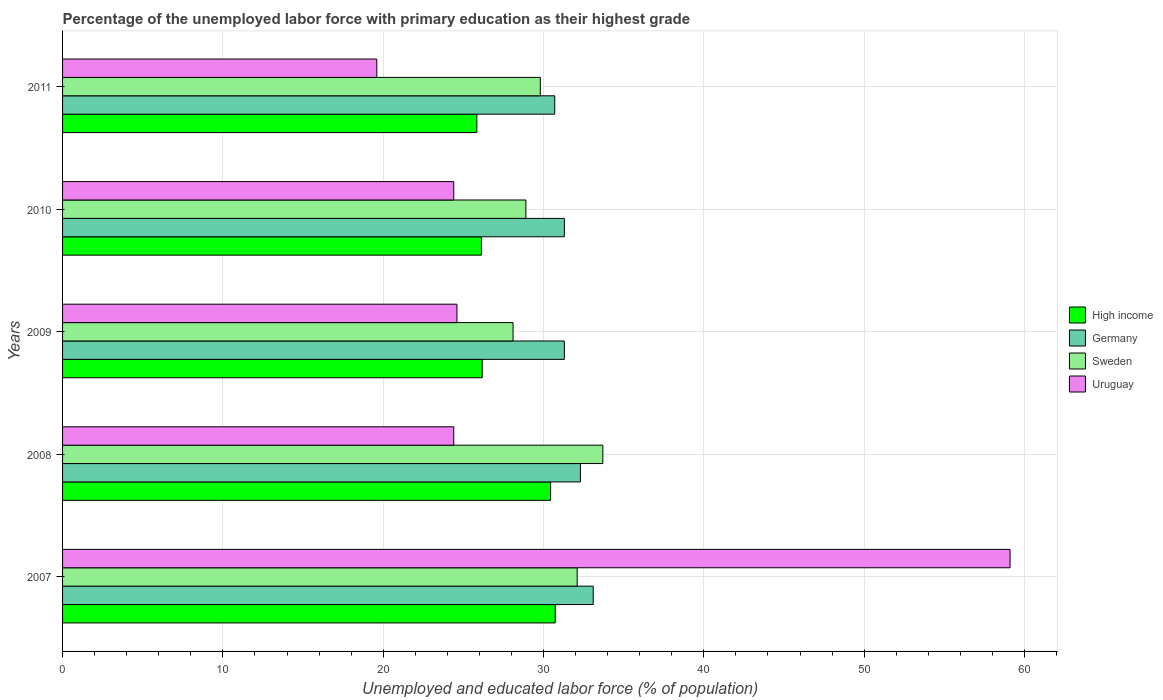Are the number of bars on each tick of the Y-axis equal?
Give a very brief answer. Yes. How many bars are there on the 3rd tick from the top?
Give a very brief answer. 4. How many bars are there on the 4th tick from the bottom?
Offer a very short reply. 4. What is the label of the 5th group of bars from the top?
Ensure brevity in your answer.  2007. What is the percentage of the unemployed labor force with primary education in Germany in 2011?
Provide a succinct answer. 30.7. Across all years, what is the maximum percentage of the unemployed labor force with primary education in Sweden?
Offer a very short reply. 33.7. Across all years, what is the minimum percentage of the unemployed labor force with primary education in High income?
Offer a terse response. 25.84. What is the total percentage of the unemployed labor force with primary education in Germany in the graph?
Give a very brief answer. 158.7. What is the difference between the percentage of the unemployed labor force with primary education in High income in 2008 and that in 2010?
Give a very brief answer. 4.32. What is the difference between the percentage of the unemployed labor force with primary education in Uruguay in 2011 and the percentage of the unemployed labor force with primary education in Germany in 2008?
Make the answer very short. -12.7. What is the average percentage of the unemployed labor force with primary education in Sweden per year?
Offer a terse response. 30.52. In the year 2011, what is the difference between the percentage of the unemployed labor force with primary education in Uruguay and percentage of the unemployed labor force with primary education in Germany?
Ensure brevity in your answer.  -11.1. What is the ratio of the percentage of the unemployed labor force with primary education in Sweden in 2008 to that in 2009?
Your response must be concise. 1.2. What is the difference between the highest and the second highest percentage of the unemployed labor force with primary education in Sweden?
Provide a succinct answer. 1.6. What is the difference between the highest and the lowest percentage of the unemployed labor force with primary education in Sweden?
Provide a succinct answer. 5.6. In how many years, is the percentage of the unemployed labor force with primary education in Sweden greater than the average percentage of the unemployed labor force with primary education in Sweden taken over all years?
Ensure brevity in your answer.  2. Is the sum of the percentage of the unemployed labor force with primary education in Sweden in 2008 and 2011 greater than the maximum percentage of the unemployed labor force with primary education in High income across all years?
Offer a very short reply. Yes. What does the 1st bar from the top in 2010 represents?
Your response must be concise. Uruguay. What does the 4th bar from the bottom in 2007 represents?
Provide a succinct answer. Uruguay. How many bars are there?
Offer a terse response. 20. Are all the bars in the graph horizontal?
Make the answer very short. Yes. Does the graph contain any zero values?
Give a very brief answer. No. Where does the legend appear in the graph?
Provide a short and direct response. Center right. How are the legend labels stacked?
Provide a short and direct response. Vertical. What is the title of the graph?
Give a very brief answer. Percentage of the unemployed labor force with primary education as their highest grade. Does "United Arab Emirates" appear as one of the legend labels in the graph?
Your answer should be very brief. No. What is the label or title of the X-axis?
Provide a succinct answer. Unemployed and educated labor force (% of population). What is the label or title of the Y-axis?
Give a very brief answer. Years. What is the Unemployed and educated labor force (% of population) in High income in 2007?
Keep it short and to the point. 30.73. What is the Unemployed and educated labor force (% of population) in Germany in 2007?
Your answer should be very brief. 33.1. What is the Unemployed and educated labor force (% of population) of Sweden in 2007?
Provide a short and direct response. 32.1. What is the Unemployed and educated labor force (% of population) in Uruguay in 2007?
Offer a terse response. 59.1. What is the Unemployed and educated labor force (% of population) of High income in 2008?
Provide a short and direct response. 30.44. What is the Unemployed and educated labor force (% of population) in Germany in 2008?
Keep it short and to the point. 32.3. What is the Unemployed and educated labor force (% of population) of Sweden in 2008?
Ensure brevity in your answer.  33.7. What is the Unemployed and educated labor force (% of population) in Uruguay in 2008?
Give a very brief answer. 24.4. What is the Unemployed and educated labor force (% of population) in High income in 2009?
Keep it short and to the point. 26.18. What is the Unemployed and educated labor force (% of population) in Germany in 2009?
Your answer should be very brief. 31.3. What is the Unemployed and educated labor force (% of population) in Sweden in 2009?
Your answer should be very brief. 28.1. What is the Unemployed and educated labor force (% of population) of Uruguay in 2009?
Your answer should be compact. 24.6. What is the Unemployed and educated labor force (% of population) in High income in 2010?
Provide a short and direct response. 26.13. What is the Unemployed and educated labor force (% of population) of Germany in 2010?
Your answer should be very brief. 31.3. What is the Unemployed and educated labor force (% of population) of Sweden in 2010?
Provide a succinct answer. 28.9. What is the Unemployed and educated labor force (% of population) of Uruguay in 2010?
Your answer should be compact. 24.4. What is the Unemployed and educated labor force (% of population) of High income in 2011?
Your answer should be compact. 25.84. What is the Unemployed and educated labor force (% of population) in Germany in 2011?
Your answer should be very brief. 30.7. What is the Unemployed and educated labor force (% of population) in Sweden in 2011?
Your answer should be compact. 29.8. What is the Unemployed and educated labor force (% of population) in Uruguay in 2011?
Make the answer very short. 19.6. Across all years, what is the maximum Unemployed and educated labor force (% of population) in High income?
Keep it short and to the point. 30.73. Across all years, what is the maximum Unemployed and educated labor force (% of population) in Germany?
Keep it short and to the point. 33.1. Across all years, what is the maximum Unemployed and educated labor force (% of population) of Sweden?
Keep it short and to the point. 33.7. Across all years, what is the maximum Unemployed and educated labor force (% of population) in Uruguay?
Offer a terse response. 59.1. Across all years, what is the minimum Unemployed and educated labor force (% of population) of High income?
Your answer should be very brief. 25.84. Across all years, what is the minimum Unemployed and educated labor force (% of population) of Germany?
Give a very brief answer. 30.7. Across all years, what is the minimum Unemployed and educated labor force (% of population) in Sweden?
Offer a terse response. 28.1. Across all years, what is the minimum Unemployed and educated labor force (% of population) of Uruguay?
Make the answer very short. 19.6. What is the total Unemployed and educated labor force (% of population) in High income in the graph?
Your answer should be very brief. 139.32. What is the total Unemployed and educated labor force (% of population) of Germany in the graph?
Offer a terse response. 158.7. What is the total Unemployed and educated labor force (% of population) in Sweden in the graph?
Make the answer very short. 152.6. What is the total Unemployed and educated labor force (% of population) of Uruguay in the graph?
Your answer should be compact. 152.1. What is the difference between the Unemployed and educated labor force (% of population) of High income in 2007 and that in 2008?
Your response must be concise. 0.29. What is the difference between the Unemployed and educated labor force (% of population) of Germany in 2007 and that in 2008?
Offer a terse response. 0.8. What is the difference between the Unemployed and educated labor force (% of population) in Uruguay in 2007 and that in 2008?
Offer a terse response. 34.7. What is the difference between the Unemployed and educated labor force (% of population) of High income in 2007 and that in 2009?
Make the answer very short. 4.55. What is the difference between the Unemployed and educated labor force (% of population) of Germany in 2007 and that in 2009?
Your answer should be very brief. 1.8. What is the difference between the Unemployed and educated labor force (% of population) of Uruguay in 2007 and that in 2009?
Make the answer very short. 34.5. What is the difference between the Unemployed and educated labor force (% of population) in High income in 2007 and that in 2010?
Provide a short and direct response. 4.61. What is the difference between the Unemployed and educated labor force (% of population) in Sweden in 2007 and that in 2010?
Offer a terse response. 3.2. What is the difference between the Unemployed and educated labor force (% of population) in Uruguay in 2007 and that in 2010?
Make the answer very short. 34.7. What is the difference between the Unemployed and educated labor force (% of population) of High income in 2007 and that in 2011?
Offer a very short reply. 4.89. What is the difference between the Unemployed and educated labor force (% of population) of Germany in 2007 and that in 2011?
Offer a very short reply. 2.4. What is the difference between the Unemployed and educated labor force (% of population) in Uruguay in 2007 and that in 2011?
Offer a very short reply. 39.5. What is the difference between the Unemployed and educated labor force (% of population) in High income in 2008 and that in 2009?
Make the answer very short. 4.26. What is the difference between the Unemployed and educated labor force (% of population) of Uruguay in 2008 and that in 2009?
Your response must be concise. -0.2. What is the difference between the Unemployed and educated labor force (% of population) in High income in 2008 and that in 2010?
Provide a short and direct response. 4.32. What is the difference between the Unemployed and educated labor force (% of population) of Sweden in 2008 and that in 2010?
Offer a very short reply. 4.8. What is the difference between the Unemployed and educated labor force (% of population) in High income in 2008 and that in 2011?
Provide a succinct answer. 4.6. What is the difference between the Unemployed and educated labor force (% of population) of Germany in 2008 and that in 2011?
Ensure brevity in your answer.  1.6. What is the difference between the Unemployed and educated labor force (% of population) of Sweden in 2008 and that in 2011?
Ensure brevity in your answer.  3.9. What is the difference between the Unemployed and educated labor force (% of population) in Uruguay in 2008 and that in 2011?
Provide a short and direct response. 4.8. What is the difference between the Unemployed and educated labor force (% of population) of High income in 2009 and that in 2010?
Ensure brevity in your answer.  0.05. What is the difference between the Unemployed and educated labor force (% of population) of Uruguay in 2009 and that in 2010?
Offer a very short reply. 0.2. What is the difference between the Unemployed and educated labor force (% of population) in High income in 2009 and that in 2011?
Provide a succinct answer. 0.33. What is the difference between the Unemployed and educated labor force (% of population) in Uruguay in 2009 and that in 2011?
Your answer should be very brief. 5. What is the difference between the Unemployed and educated labor force (% of population) of High income in 2010 and that in 2011?
Offer a terse response. 0.28. What is the difference between the Unemployed and educated labor force (% of population) of Uruguay in 2010 and that in 2011?
Make the answer very short. 4.8. What is the difference between the Unemployed and educated labor force (% of population) in High income in 2007 and the Unemployed and educated labor force (% of population) in Germany in 2008?
Your answer should be very brief. -1.57. What is the difference between the Unemployed and educated labor force (% of population) in High income in 2007 and the Unemployed and educated labor force (% of population) in Sweden in 2008?
Make the answer very short. -2.97. What is the difference between the Unemployed and educated labor force (% of population) in High income in 2007 and the Unemployed and educated labor force (% of population) in Uruguay in 2008?
Your response must be concise. 6.33. What is the difference between the Unemployed and educated labor force (% of population) in High income in 2007 and the Unemployed and educated labor force (% of population) in Germany in 2009?
Offer a very short reply. -0.57. What is the difference between the Unemployed and educated labor force (% of population) in High income in 2007 and the Unemployed and educated labor force (% of population) in Sweden in 2009?
Give a very brief answer. 2.63. What is the difference between the Unemployed and educated labor force (% of population) in High income in 2007 and the Unemployed and educated labor force (% of population) in Uruguay in 2009?
Make the answer very short. 6.13. What is the difference between the Unemployed and educated labor force (% of population) in Germany in 2007 and the Unemployed and educated labor force (% of population) in Uruguay in 2009?
Offer a very short reply. 8.5. What is the difference between the Unemployed and educated labor force (% of population) in Sweden in 2007 and the Unemployed and educated labor force (% of population) in Uruguay in 2009?
Provide a succinct answer. 7.5. What is the difference between the Unemployed and educated labor force (% of population) in High income in 2007 and the Unemployed and educated labor force (% of population) in Germany in 2010?
Provide a succinct answer. -0.57. What is the difference between the Unemployed and educated labor force (% of population) of High income in 2007 and the Unemployed and educated labor force (% of population) of Sweden in 2010?
Ensure brevity in your answer.  1.83. What is the difference between the Unemployed and educated labor force (% of population) of High income in 2007 and the Unemployed and educated labor force (% of population) of Uruguay in 2010?
Your answer should be compact. 6.33. What is the difference between the Unemployed and educated labor force (% of population) of Germany in 2007 and the Unemployed and educated labor force (% of population) of Sweden in 2010?
Provide a short and direct response. 4.2. What is the difference between the Unemployed and educated labor force (% of population) of High income in 2007 and the Unemployed and educated labor force (% of population) of Germany in 2011?
Keep it short and to the point. 0.03. What is the difference between the Unemployed and educated labor force (% of population) in High income in 2007 and the Unemployed and educated labor force (% of population) in Sweden in 2011?
Offer a terse response. 0.93. What is the difference between the Unemployed and educated labor force (% of population) of High income in 2007 and the Unemployed and educated labor force (% of population) of Uruguay in 2011?
Provide a succinct answer. 11.13. What is the difference between the Unemployed and educated labor force (% of population) of High income in 2008 and the Unemployed and educated labor force (% of population) of Germany in 2009?
Offer a terse response. -0.86. What is the difference between the Unemployed and educated labor force (% of population) of High income in 2008 and the Unemployed and educated labor force (% of population) of Sweden in 2009?
Your answer should be very brief. 2.34. What is the difference between the Unemployed and educated labor force (% of population) of High income in 2008 and the Unemployed and educated labor force (% of population) of Uruguay in 2009?
Keep it short and to the point. 5.84. What is the difference between the Unemployed and educated labor force (% of population) of Germany in 2008 and the Unemployed and educated labor force (% of population) of Uruguay in 2009?
Keep it short and to the point. 7.7. What is the difference between the Unemployed and educated labor force (% of population) of High income in 2008 and the Unemployed and educated labor force (% of population) of Germany in 2010?
Provide a succinct answer. -0.86. What is the difference between the Unemployed and educated labor force (% of population) of High income in 2008 and the Unemployed and educated labor force (% of population) of Sweden in 2010?
Offer a very short reply. 1.54. What is the difference between the Unemployed and educated labor force (% of population) of High income in 2008 and the Unemployed and educated labor force (% of population) of Uruguay in 2010?
Give a very brief answer. 6.04. What is the difference between the Unemployed and educated labor force (% of population) in Germany in 2008 and the Unemployed and educated labor force (% of population) in Uruguay in 2010?
Keep it short and to the point. 7.9. What is the difference between the Unemployed and educated labor force (% of population) of Sweden in 2008 and the Unemployed and educated labor force (% of population) of Uruguay in 2010?
Offer a very short reply. 9.3. What is the difference between the Unemployed and educated labor force (% of population) of High income in 2008 and the Unemployed and educated labor force (% of population) of Germany in 2011?
Your answer should be very brief. -0.26. What is the difference between the Unemployed and educated labor force (% of population) in High income in 2008 and the Unemployed and educated labor force (% of population) in Sweden in 2011?
Ensure brevity in your answer.  0.64. What is the difference between the Unemployed and educated labor force (% of population) in High income in 2008 and the Unemployed and educated labor force (% of population) in Uruguay in 2011?
Provide a succinct answer. 10.84. What is the difference between the Unemployed and educated labor force (% of population) in High income in 2009 and the Unemployed and educated labor force (% of population) in Germany in 2010?
Keep it short and to the point. -5.12. What is the difference between the Unemployed and educated labor force (% of population) in High income in 2009 and the Unemployed and educated labor force (% of population) in Sweden in 2010?
Keep it short and to the point. -2.72. What is the difference between the Unemployed and educated labor force (% of population) in High income in 2009 and the Unemployed and educated labor force (% of population) in Uruguay in 2010?
Your answer should be very brief. 1.78. What is the difference between the Unemployed and educated labor force (% of population) in Germany in 2009 and the Unemployed and educated labor force (% of population) in Sweden in 2010?
Offer a very short reply. 2.4. What is the difference between the Unemployed and educated labor force (% of population) of Germany in 2009 and the Unemployed and educated labor force (% of population) of Uruguay in 2010?
Your answer should be compact. 6.9. What is the difference between the Unemployed and educated labor force (% of population) of High income in 2009 and the Unemployed and educated labor force (% of population) of Germany in 2011?
Provide a succinct answer. -4.52. What is the difference between the Unemployed and educated labor force (% of population) of High income in 2009 and the Unemployed and educated labor force (% of population) of Sweden in 2011?
Provide a short and direct response. -3.62. What is the difference between the Unemployed and educated labor force (% of population) of High income in 2009 and the Unemployed and educated labor force (% of population) of Uruguay in 2011?
Give a very brief answer. 6.58. What is the difference between the Unemployed and educated labor force (% of population) of Germany in 2009 and the Unemployed and educated labor force (% of population) of Uruguay in 2011?
Your response must be concise. 11.7. What is the difference between the Unemployed and educated labor force (% of population) of High income in 2010 and the Unemployed and educated labor force (% of population) of Germany in 2011?
Give a very brief answer. -4.58. What is the difference between the Unemployed and educated labor force (% of population) in High income in 2010 and the Unemployed and educated labor force (% of population) in Sweden in 2011?
Ensure brevity in your answer.  -3.67. What is the difference between the Unemployed and educated labor force (% of population) of High income in 2010 and the Unemployed and educated labor force (% of population) of Uruguay in 2011?
Offer a terse response. 6.53. What is the difference between the Unemployed and educated labor force (% of population) in Germany in 2010 and the Unemployed and educated labor force (% of population) in Sweden in 2011?
Your answer should be compact. 1.5. What is the difference between the Unemployed and educated labor force (% of population) in Sweden in 2010 and the Unemployed and educated labor force (% of population) in Uruguay in 2011?
Provide a succinct answer. 9.3. What is the average Unemployed and educated labor force (% of population) of High income per year?
Offer a terse response. 27.86. What is the average Unemployed and educated labor force (% of population) of Germany per year?
Provide a short and direct response. 31.74. What is the average Unemployed and educated labor force (% of population) in Sweden per year?
Your answer should be compact. 30.52. What is the average Unemployed and educated labor force (% of population) in Uruguay per year?
Provide a succinct answer. 30.42. In the year 2007, what is the difference between the Unemployed and educated labor force (% of population) of High income and Unemployed and educated labor force (% of population) of Germany?
Your answer should be compact. -2.37. In the year 2007, what is the difference between the Unemployed and educated labor force (% of population) of High income and Unemployed and educated labor force (% of population) of Sweden?
Ensure brevity in your answer.  -1.37. In the year 2007, what is the difference between the Unemployed and educated labor force (% of population) of High income and Unemployed and educated labor force (% of population) of Uruguay?
Your response must be concise. -28.37. In the year 2007, what is the difference between the Unemployed and educated labor force (% of population) in Germany and Unemployed and educated labor force (% of population) in Sweden?
Ensure brevity in your answer.  1. In the year 2007, what is the difference between the Unemployed and educated labor force (% of population) in Germany and Unemployed and educated labor force (% of population) in Uruguay?
Offer a very short reply. -26. In the year 2007, what is the difference between the Unemployed and educated labor force (% of population) in Sweden and Unemployed and educated labor force (% of population) in Uruguay?
Offer a very short reply. -27. In the year 2008, what is the difference between the Unemployed and educated labor force (% of population) in High income and Unemployed and educated labor force (% of population) in Germany?
Give a very brief answer. -1.86. In the year 2008, what is the difference between the Unemployed and educated labor force (% of population) of High income and Unemployed and educated labor force (% of population) of Sweden?
Provide a succinct answer. -3.26. In the year 2008, what is the difference between the Unemployed and educated labor force (% of population) of High income and Unemployed and educated labor force (% of population) of Uruguay?
Your answer should be very brief. 6.04. In the year 2008, what is the difference between the Unemployed and educated labor force (% of population) in Germany and Unemployed and educated labor force (% of population) in Sweden?
Offer a terse response. -1.4. In the year 2008, what is the difference between the Unemployed and educated labor force (% of population) of Sweden and Unemployed and educated labor force (% of population) of Uruguay?
Give a very brief answer. 9.3. In the year 2009, what is the difference between the Unemployed and educated labor force (% of population) of High income and Unemployed and educated labor force (% of population) of Germany?
Your response must be concise. -5.12. In the year 2009, what is the difference between the Unemployed and educated labor force (% of population) in High income and Unemployed and educated labor force (% of population) in Sweden?
Provide a succinct answer. -1.92. In the year 2009, what is the difference between the Unemployed and educated labor force (% of population) of High income and Unemployed and educated labor force (% of population) of Uruguay?
Your answer should be very brief. 1.58. In the year 2010, what is the difference between the Unemployed and educated labor force (% of population) in High income and Unemployed and educated labor force (% of population) in Germany?
Give a very brief answer. -5.17. In the year 2010, what is the difference between the Unemployed and educated labor force (% of population) of High income and Unemployed and educated labor force (% of population) of Sweden?
Provide a succinct answer. -2.77. In the year 2010, what is the difference between the Unemployed and educated labor force (% of population) of High income and Unemployed and educated labor force (% of population) of Uruguay?
Give a very brief answer. 1.73. In the year 2010, what is the difference between the Unemployed and educated labor force (% of population) in Sweden and Unemployed and educated labor force (% of population) in Uruguay?
Provide a succinct answer. 4.5. In the year 2011, what is the difference between the Unemployed and educated labor force (% of population) of High income and Unemployed and educated labor force (% of population) of Germany?
Make the answer very short. -4.86. In the year 2011, what is the difference between the Unemployed and educated labor force (% of population) in High income and Unemployed and educated labor force (% of population) in Sweden?
Keep it short and to the point. -3.96. In the year 2011, what is the difference between the Unemployed and educated labor force (% of population) of High income and Unemployed and educated labor force (% of population) of Uruguay?
Keep it short and to the point. 6.24. In the year 2011, what is the difference between the Unemployed and educated labor force (% of population) of Germany and Unemployed and educated labor force (% of population) of Sweden?
Provide a succinct answer. 0.9. In the year 2011, what is the difference between the Unemployed and educated labor force (% of population) in Germany and Unemployed and educated labor force (% of population) in Uruguay?
Make the answer very short. 11.1. In the year 2011, what is the difference between the Unemployed and educated labor force (% of population) in Sweden and Unemployed and educated labor force (% of population) in Uruguay?
Keep it short and to the point. 10.2. What is the ratio of the Unemployed and educated labor force (% of population) of High income in 2007 to that in 2008?
Your answer should be compact. 1.01. What is the ratio of the Unemployed and educated labor force (% of population) of Germany in 2007 to that in 2008?
Your answer should be compact. 1.02. What is the ratio of the Unemployed and educated labor force (% of population) in Sweden in 2007 to that in 2008?
Your answer should be compact. 0.95. What is the ratio of the Unemployed and educated labor force (% of population) in Uruguay in 2007 to that in 2008?
Your answer should be compact. 2.42. What is the ratio of the Unemployed and educated labor force (% of population) of High income in 2007 to that in 2009?
Your answer should be very brief. 1.17. What is the ratio of the Unemployed and educated labor force (% of population) in Germany in 2007 to that in 2009?
Make the answer very short. 1.06. What is the ratio of the Unemployed and educated labor force (% of population) of Sweden in 2007 to that in 2009?
Your answer should be very brief. 1.14. What is the ratio of the Unemployed and educated labor force (% of population) of Uruguay in 2007 to that in 2009?
Your answer should be compact. 2.4. What is the ratio of the Unemployed and educated labor force (% of population) of High income in 2007 to that in 2010?
Your answer should be compact. 1.18. What is the ratio of the Unemployed and educated labor force (% of population) of Germany in 2007 to that in 2010?
Offer a terse response. 1.06. What is the ratio of the Unemployed and educated labor force (% of population) in Sweden in 2007 to that in 2010?
Keep it short and to the point. 1.11. What is the ratio of the Unemployed and educated labor force (% of population) in Uruguay in 2007 to that in 2010?
Your answer should be compact. 2.42. What is the ratio of the Unemployed and educated labor force (% of population) of High income in 2007 to that in 2011?
Your answer should be compact. 1.19. What is the ratio of the Unemployed and educated labor force (% of population) of Germany in 2007 to that in 2011?
Your answer should be very brief. 1.08. What is the ratio of the Unemployed and educated labor force (% of population) of Sweden in 2007 to that in 2011?
Your answer should be compact. 1.08. What is the ratio of the Unemployed and educated labor force (% of population) in Uruguay in 2007 to that in 2011?
Offer a very short reply. 3.02. What is the ratio of the Unemployed and educated labor force (% of population) in High income in 2008 to that in 2009?
Make the answer very short. 1.16. What is the ratio of the Unemployed and educated labor force (% of population) of Germany in 2008 to that in 2009?
Make the answer very short. 1.03. What is the ratio of the Unemployed and educated labor force (% of population) in Sweden in 2008 to that in 2009?
Keep it short and to the point. 1.2. What is the ratio of the Unemployed and educated labor force (% of population) of High income in 2008 to that in 2010?
Ensure brevity in your answer.  1.17. What is the ratio of the Unemployed and educated labor force (% of population) in Germany in 2008 to that in 2010?
Offer a very short reply. 1.03. What is the ratio of the Unemployed and educated labor force (% of population) in Sweden in 2008 to that in 2010?
Your response must be concise. 1.17. What is the ratio of the Unemployed and educated labor force (% of population) of Uruguay in 2008 to that in 2010?
Keep it short and to the point. 1. What is the ratio of the Unemployed and educated labor force (% of population) of High income in 2008 to that in 2011?
Provide a succinct answer. 1.18. What is the ratio of the Unemployed and educated labor force (% of population) in Germany in 2008 to that in 2011?
Your answer should be compact. 1.05. What is the ratio of the Unemployed and educated labor force (% of population) of Sweden in 2008 to that in 2011?
Keep it short and to the point. 1.13. What is the ratio of the Unemployed and educated labor force (% of population) in Uruguay in 2008 to that in 2011?
Provide a short and direct response. 1.24. What is the ratio of the Unemployed and educated labor force (% of population) of High income in 2009 to that in 2010?
Your answer should be compact. 1. What is the ratio of the Unemployed and educated labor force (% of population) of Germany in 2009 to that in 2010?
Keep it short and to the point. 1. What is the ratio of the Unemployed and educated labor force (% of population) in Sweden in 2009 to that in 2010?
Your response must be concise. 0.97. What is the ratio of the Unemployed and educated labor force (% of population) of Uruguay in 2009 to that in 2010?
Offer a terse response. 1.01. What is the ratio of the Unemployed and educated labor force (% of population) of High income in 2009 to that in 2011?
Provide a succinct answer. 1.01. What is the ratio of the Unemployed and educated labor force (% of population) of Germany in 2009 to that in 2011?
Your answer should be very brief. 1.02. What is the ratio of the Unemployed and educated labor force (% of population) of Sweden in 2009 to that in 2011?
Make the answer very short. 0.94. What is the ratio of the Unemployed and educated labor force (% of population) in Uruguay in 2009 to that in 2011?
Offer a very short reply. 1.26. What is the ratio of the Unemployed and educated labor force (% of population) in Germany in 2010 to that in 2011?
Offer a terse response. 1.02. What is the ratio of the Unemployed and educated labor force (% of population) of Sweden in 2010 to that in 2011?
Offer a terse response. 0.97. What is the ratio of the Unemployed and educated labor force (% of population) in Uruguay in 2010 to that in 2011?
Your answer should be compact. 1.24. What is the difference between the highest and the second highest Unemployed and educated labor force (% of population) of High income?
Make the answer very short. 0.29. What is the difference between the highest and the second highest Unemployed and educated labor force (% of population) of Germany?
Your answer should be very brief. 0.8. What is the difference between the highest and the second highest Unemployed and educated labor force (% of population) in Sweden?
Give a very brief answer. 1.6. What is the difference between the highest and the second highest Unemployed and educated labor force (% of population) of Uruguay?
Offer a very short reply. 34.5. What is the difference between the highest and the lowest Unemployed and educated labor force (% of population) of High income?
Offer a terse response. 4.89. What is the difference between the highest and the lowest Unemployed and educated labor force (% of population) in Germany?
Offer a very short reply. 2.4. What is the difference between the highest and the lowest Unemployed and educated labor force (% of population) of Sweden?
Offer a very short reply. 5.6. What is the difference between the highest and the lowest Unemployed and educated labor force (% of population) of Uruguay?
Provide a short and direct response. 39.5. 